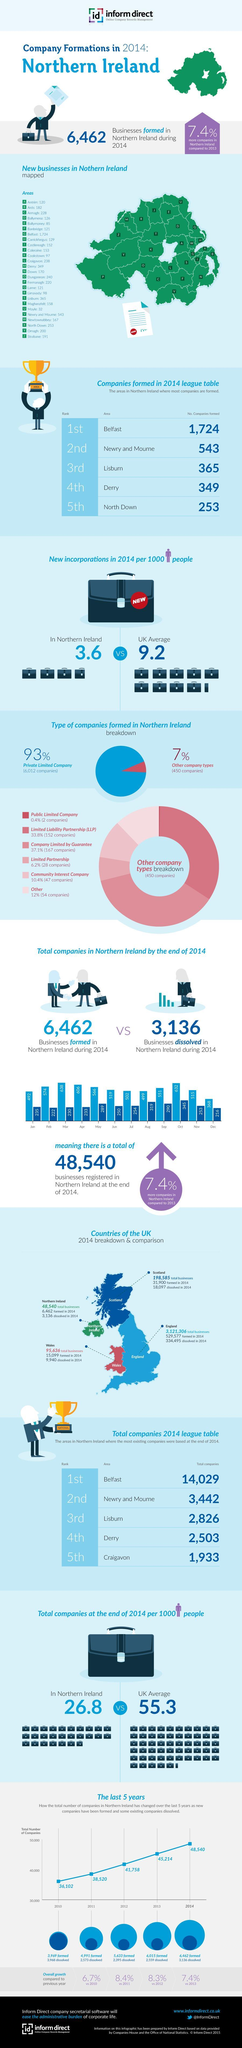How many companies were dissolved in 2014 in N. Ireland?
Answer the question with a short phrase. 3,136 Majority of companies formed are of which type? Private Limited Company By what percentage did the number companies formed increase in 2014 compared to 2013? 7.4% What was the number of private limited companies formed? 6,012 In which country of the UK were 334,495 companies dissolved in 2014? England Which is the area in Northern Ireland where the number of companies formed is between 500 - 1000? Newry and Mourne How many new incorporations in 2014 per 1000 people in Northern Ireland? 3.6 In which country of the UK were 15,099 companies formed in 2014? Wales How many areas in Northern Ireland where number of companies formed in 2014 is above 1000? 1 What was the number of LLP companies formed in 2014 in Northern Ireland? 152 